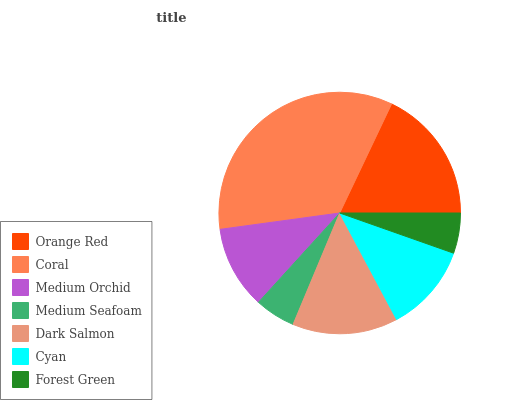Is Forest Green the minimum?
Answer yes or no. Yes. Is Coral the maximum?
Answer yes or no. Yes. Is Medium Orchid the minimum?
Answer yes or no. No. Is Medium Orchid the maximum?
Answer yes or no. No. Is Coral greater than Medium Orchid?
Answer yes or no. Yes. Is Medium Orchid less than Coral?
Answer yes or no. Yes. Is Medium Orchid greater than Coral?
Answer yes or no. No. Is Coral less than Medium Orchid?
Answer yes or no. No. Is Cyan the high median?
Answer yes or no. Yes. Is Cyan the low median?
Answer yes or no. Yes. Is Orange Red the high median?
Answer yes or no. No. Is Coral the low median?
Answer yes or no. No. 